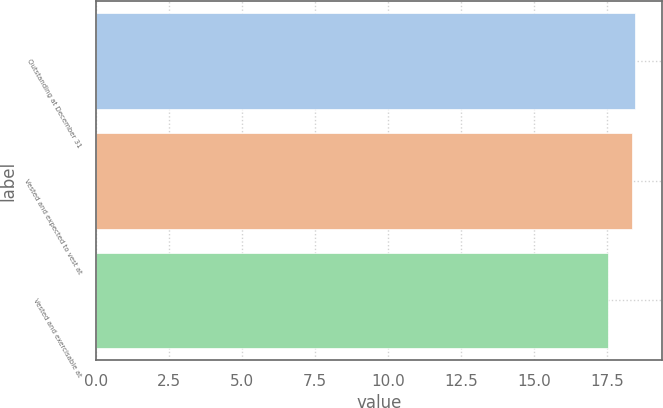<chart> <loc_0><loc_0><loc_500><loc_500><bar_chart><fcel>Outstanding at December 31<fcel>Vested and expected to vest at<fcel>Vested and exercisable at<nl><fcel>18.48<fcel>18.35<fcel>17.53<nl></chart> 